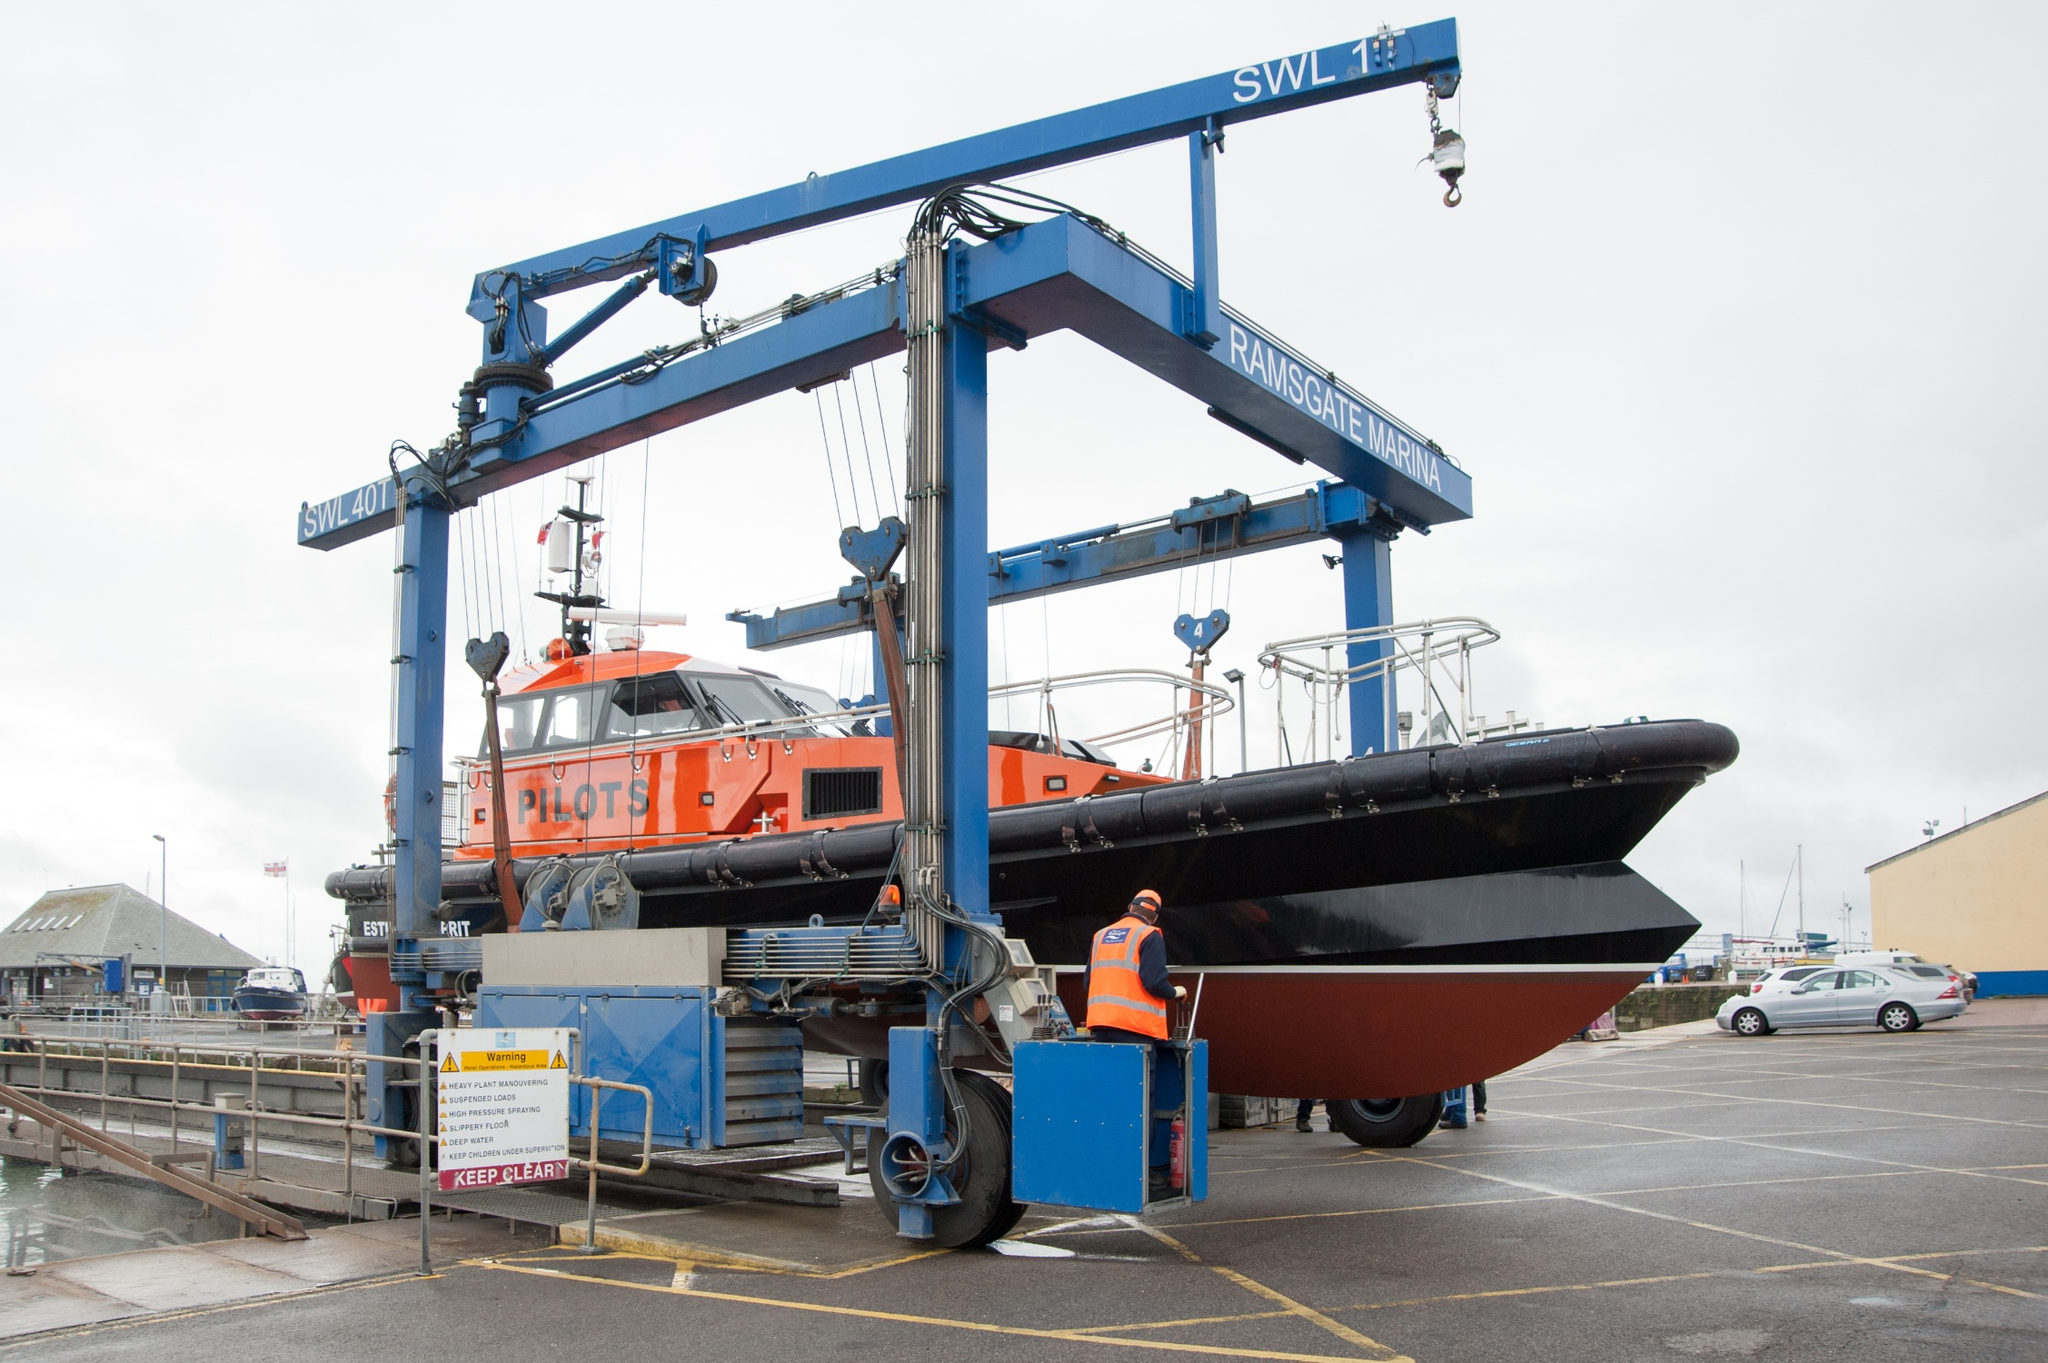What are the key elements in this picture? The image showcases a prominent blue crane marked with 'Ransomes & Rapier' operating at Ramsgate Marina, indicated by its branding atop. The crane, which has a lifting capacity of 7 tons as noted by 'SWL 7t', is currently lifting a pilot boat colored in striking black and orange with the word 'PILOTS' visible on its side. This operation highlights the machinery and work involved in maritime activities within a harbor setting. Surrounding the area, a few cars and somewhat obscured buildings provide context to the industrial environment. 